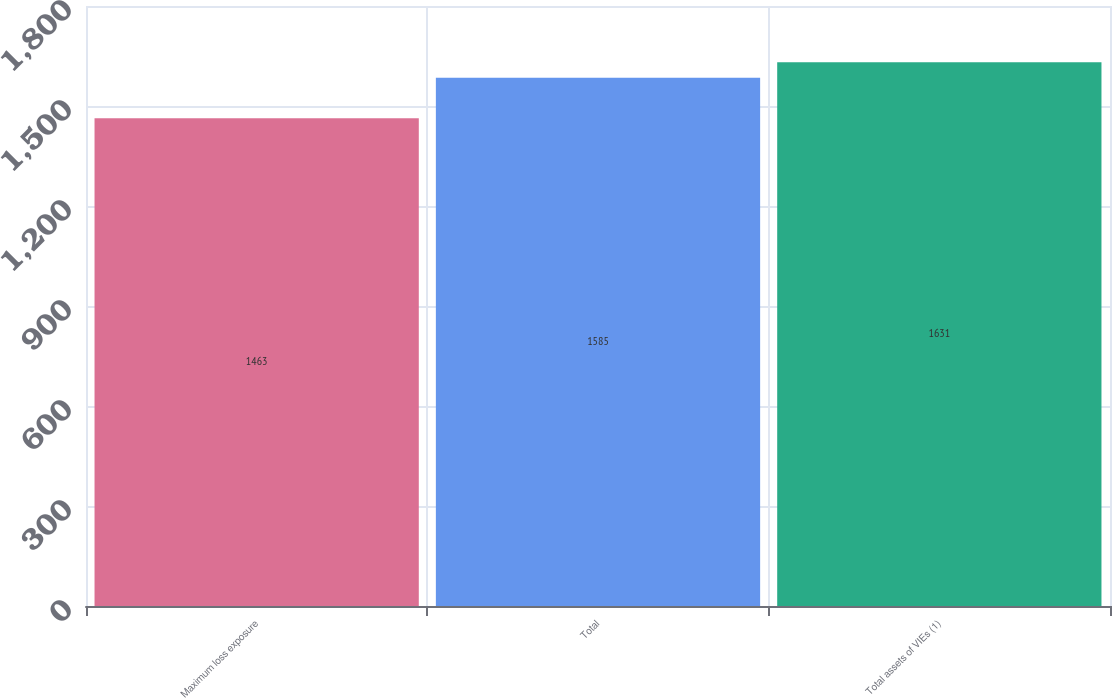Convert chart to OTSL. <chart><loc_0><loc_0><loc_500><loc_500><bar_chart><fcel>Maximum loss exposure<fcel>Total<fcel>Total assets of VIEs (1)<nl><fcel>1463<fcel>1585<fcel>1631<nl></chart> 